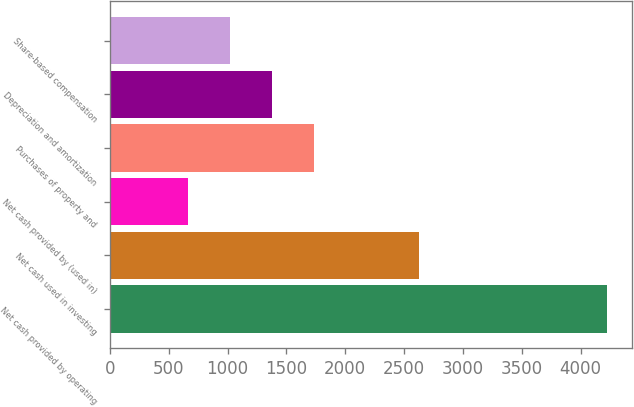Convert chart. <chart><loc_0><loc_0><loc_500><loc_500><bar_chart><fcel>Net cash provided by operating<fcel>Net cash used in investing<fcel>Net cash provided by (used in)<fcel>Purchases of property and<fcel>Depreciation and amortization<fcel>Share-based compensation<nl><fcel>4222<fcel>2624<fcel>667<fcel>1733.5<fcel>1378<fcel>1022.5<nl></chart> 